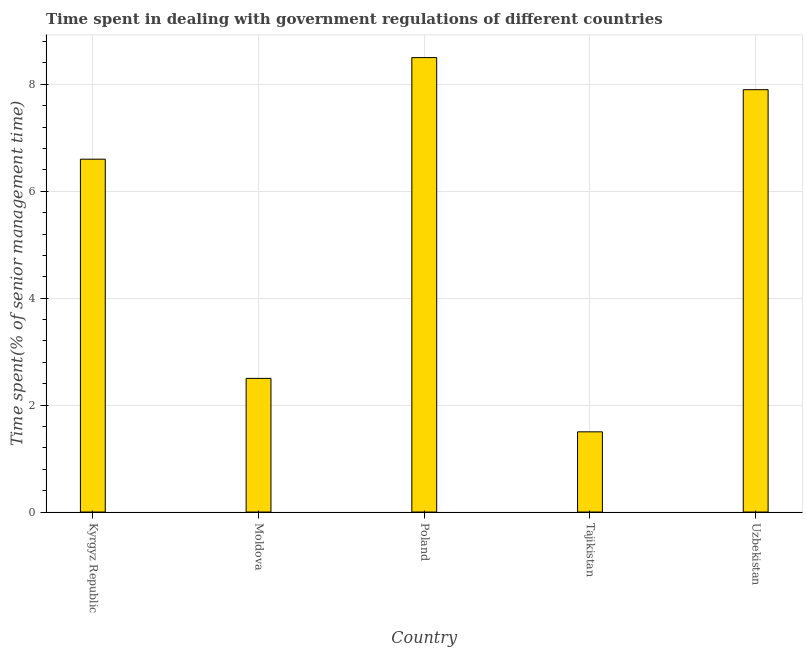Does the graph contain any zero values?
Keep it short and to the point. No. Does the graph contain grids?
Offer a terse response. Yes. What is the title of the graph?
Keep it short and to the point. Time spent in dealing with government regulations of different countries. What is the label or title of the Y-axis?
Ensure brevity in your answer.  Time spent(% of senior management time). Across all countries, what is the minimum time spent in dealing with government regulations?
Make the answer very short. 1.5. In which country was the time spent in dealing with government regulations minimum?
Offer a terse response. Tajikistan. What is the sum of the time spent in dealing with government regulations?
Make the answer very short. 27. What is the average time spent in dealing with government regulations per country?
Offer a terse response. 5.4. Is the time spent in dealing with government regulations in Poland less than that in Tajikistan?
Make the answer very short. No. Is the difference between the time spent in dealing with government regulations in Tajikistan and Uzbekistan greater than the difference between any two countries?
Offer a very short reply. No. What is the difference between the highest and the second highest time spent in dealing with government regulations?
Offer a very short reply. 0.6. Is the sum of the time spent in dealing with government regulations in Moldova and Uzbekistan greater than the maximum time spent in dealing with government regulations across all countries?
Offer a very short reply. Yes. In how many countries, is the time spent in dealing with government regulations greater than the average time spent in dealing with government regulations taken over all countries?
Offer a very short reply. 3. What is the Time spent(% of senior management time) in Kyrgyz Republic?
Your answer should be very brief. 6.6. What is the Time spent(% of senior management time) of Tajikistan?
Your answer should be compact. 1.5. What is the difference between the Time spent(% of senior management time) in Kyrgyz Republic and Tajikistan?
Your answer should be compact. 5.1. What is the difference between the Time spent(% of senior management time) in Moldova and Tajikistan?
Your answer should be very brief. 1. What is the difference between the Time spent(% of senior management time) in Poland and Uzbekistan?
Offer a terse response. 0.6. What is the difference between the Time spent(% of senior management time) in Tajikistan and Uzbekistan?
Ensure brevity in your answer.  -6.4. What is the ratio of the Time spent(% of senior management time) in Kyrgyz Republic to that in Moldova?
Give a very brief answer. 2.64. What is the ratio of the Time spent(% of senior management time) in Kyrgyz Republic to that in Poland?
Your answer should be compact. 0.78. What is the ratio of the Time spent(% of senior management time) in Kyrgyz Republic to that in Tajikistan?
Your response must be concise. 4.4. What is the ratio of the Time spent(% of senior management time) in Kyrgyz Republic to that in Uzbekistan?
Your answer should be compact. 0.83. What is the ratio of the Time spent(% of senior management time) in Moldova to that in Poland?
Keep it short and to the point. 0.29. What is the ratio of the Time spent(% of senior management time) in Moldova to that in Tajikistan?
Provide a succinct answer. 1.67. What is the ratio of the Time spent(% of senior management time) in Moldova to that in Uzbekistan?
Make the answer very short. 0.32. What is the ratio of the Time spent(% of senior management time) in Poland to that in Tajikistan?
Offer a very short reply. 5.67. What is the ratio of the Time spent(% of senior management time) in Poland to that in Uzbekistan?
Your response must be concise. 1.08. What is the ratio of the Time spent(% of senior management time) in Tajikistan to that in Uzbekistan?
Keep it short and to the point. 0.19. 